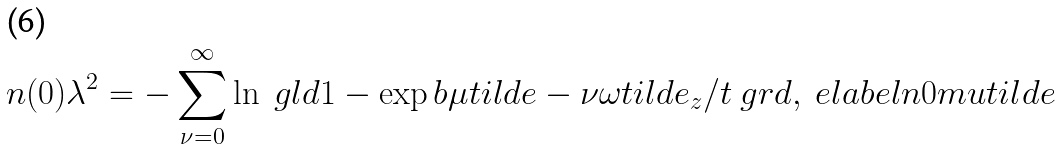Convert formula to latex. <formula><loc_0><loc_0><loc_500><loc_500>n ( 0 ) \lambda ^ { 2 } = - \sum _ { \nu = 0 } ^ { \infty } \ln \ g l d 1 - \exp b { \mu t i l d e - \nu \omega t i l d e _ { z } / t } \ g r d , \ e l a b e l { n 0 m u t i l d e }</formula> 